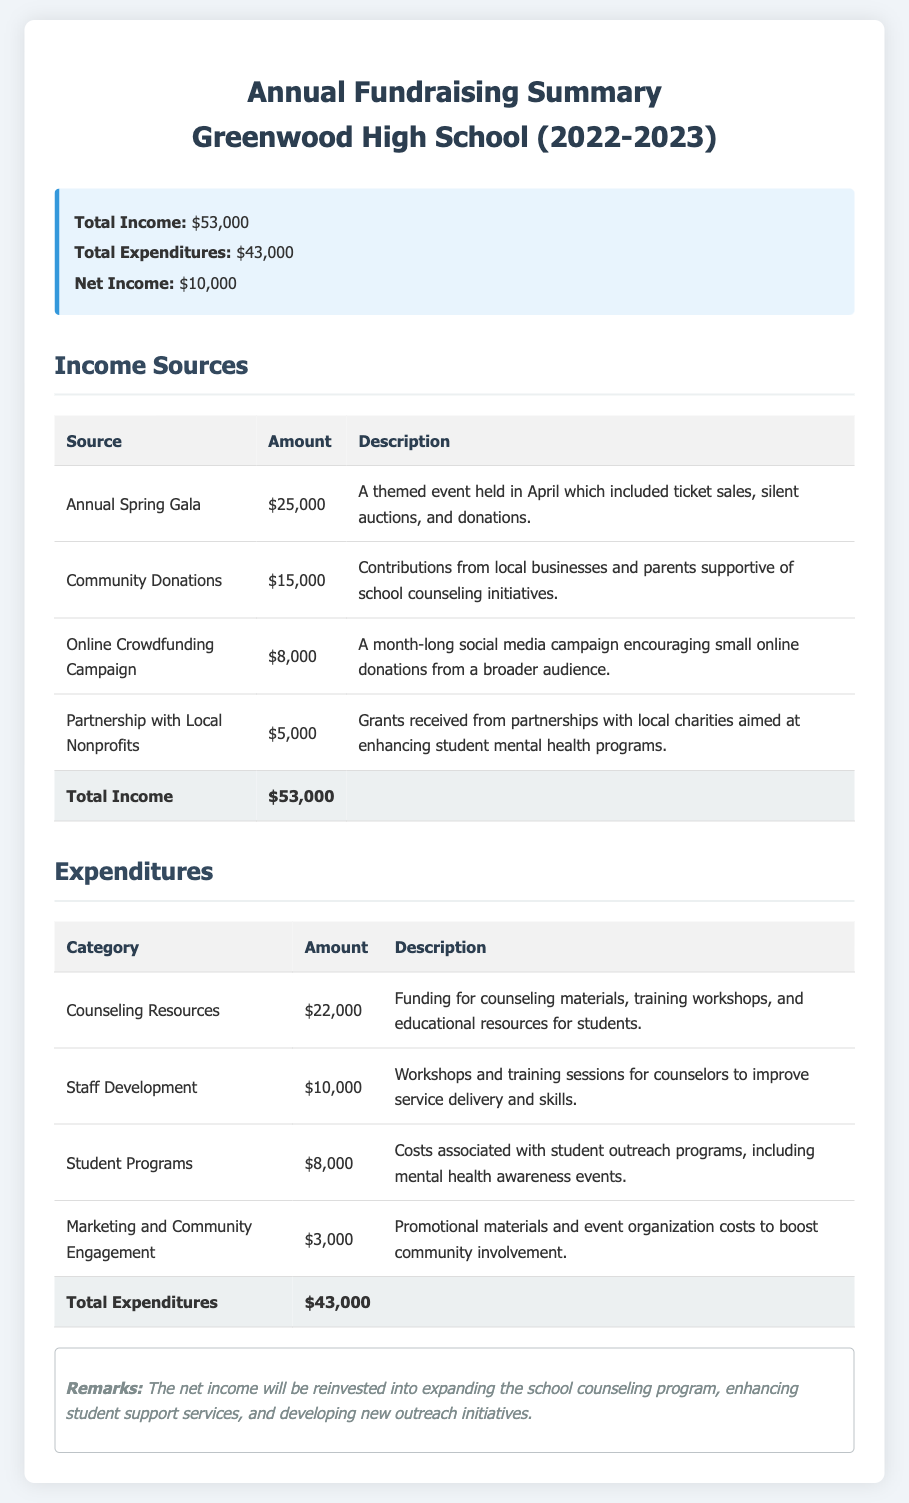What was the total income from the Annual Spring Gala? The total income from the Annual Spring Gala is listed in the document as $25,000.
Answer: $25,000 How much was spent on Counseling Resources? The amount spent on Counseling Resources is detailed in the expenditures section as $22,000.
Answer: $22,000 What is the net income for the year? The net income is calculated as total income minus total expenditures, which is stated as $10,000.
Answer: $10,000 Which income source received the least amount? The income source with the least amount, according to the income sources table, is Partnerships with Local Nonprofits at $5,000.
Answer: Partnerships with Local Nonprofits What percentage of total income was generated from Community Donations? Community Donations accounted for $15,000 of the total income, which is approximately 28.30% of $53,000.
Answer: 28.30% What is the total amount expended on Student Programs? The total amount expended on Student Programs is provided in the expenditures section as $8,000.
Answer: $8,000 What is the main purpose of the raised funds as mentioned in the remarks? The main purpose of the raised funds is to expand the school counseling program and enhance student support services.
Answer: Expand the school counseling program How many categories of expenditures are listed? The number of expenditure categories can be counted in the expenditures table, which lists four categories.
Answer: Four categories What event type contributed the most financially to the fundraising? The event that contributed the most financially to the fundraising is the Annual Spring Gala.
Answer: Annual Spring Gala 